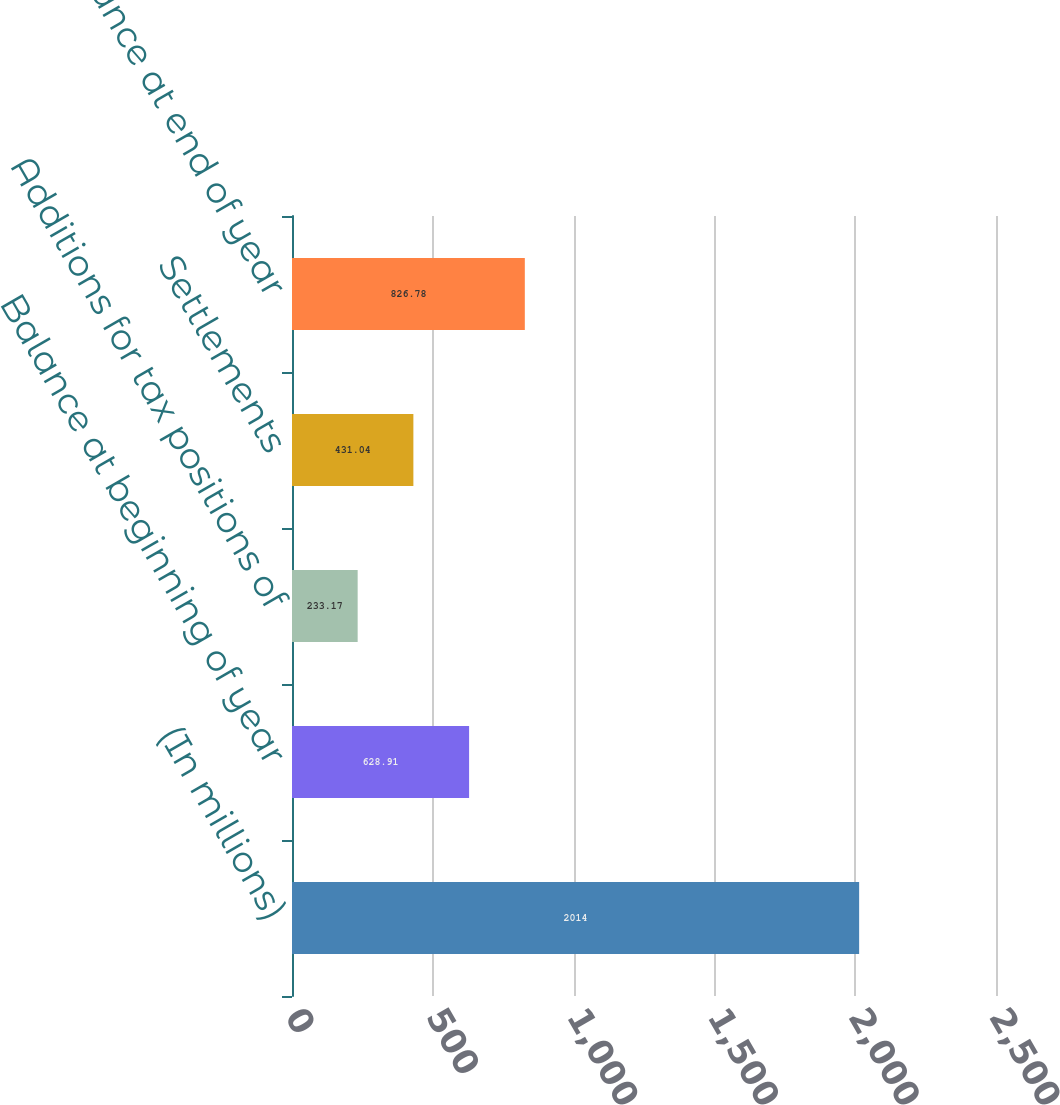Convert chart to OTSL. <chart><loc_0><loc_0><loc_500><loc_500><bar_chart><fcel>(In millions)<fcel>Balance at beginning of year<fcel>Additions for tax positions of<fcel>Settlements<fcel>Balance at end of year<nl><fcel>2014<fcel>628.91<fcel>233.17<fcel>431.04<fcel>826.78<nl></chart> 